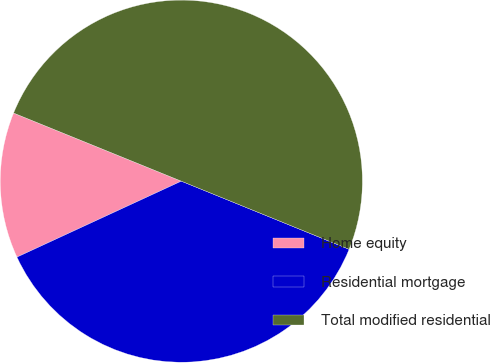<chart> <loc_0><loc_0><loc_500><loc_500><pie_chart><fcel>Home equity<fcel>Residential mortgage<fcel>Total modified residential<nl><fcel>13.03%<fcel>36.97%<fcel>50.0%<nl></chart> 